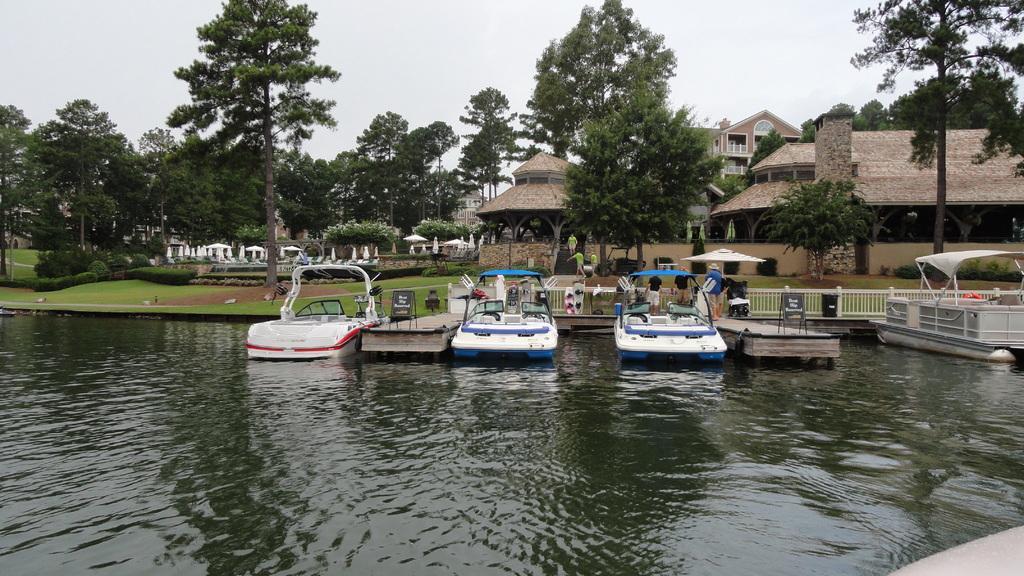Please provide a concise description of this image. At the bottom of this image, there is water on which there are boats parked. In front of them, there is a fence. In the background, there are buildings, trees, plants and grass on the ground and there are clouds in the sky. 